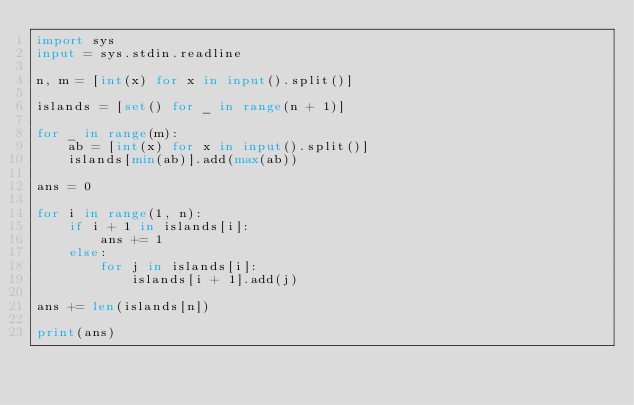<code> <loc_0><loc_0><loc_500><loc_500><_Python_>import sys
input = sys.stdin.readline

n, m = [int(x) for x in input().split()]

islands = [set() for _ in range(n + 1)]

for _ in range(m):
    ab = [int(x) for x in input().split()]
    islands[min(ab)].add(max(ab))

ans = 0

for i in range(1, n):
    if i + 1 in islands[i]:
        ans += 1
    else:
        for j in islands[i]:
            islands[i + 1].add(j)

ans += len(islands[n])

print(ans)
</code> 